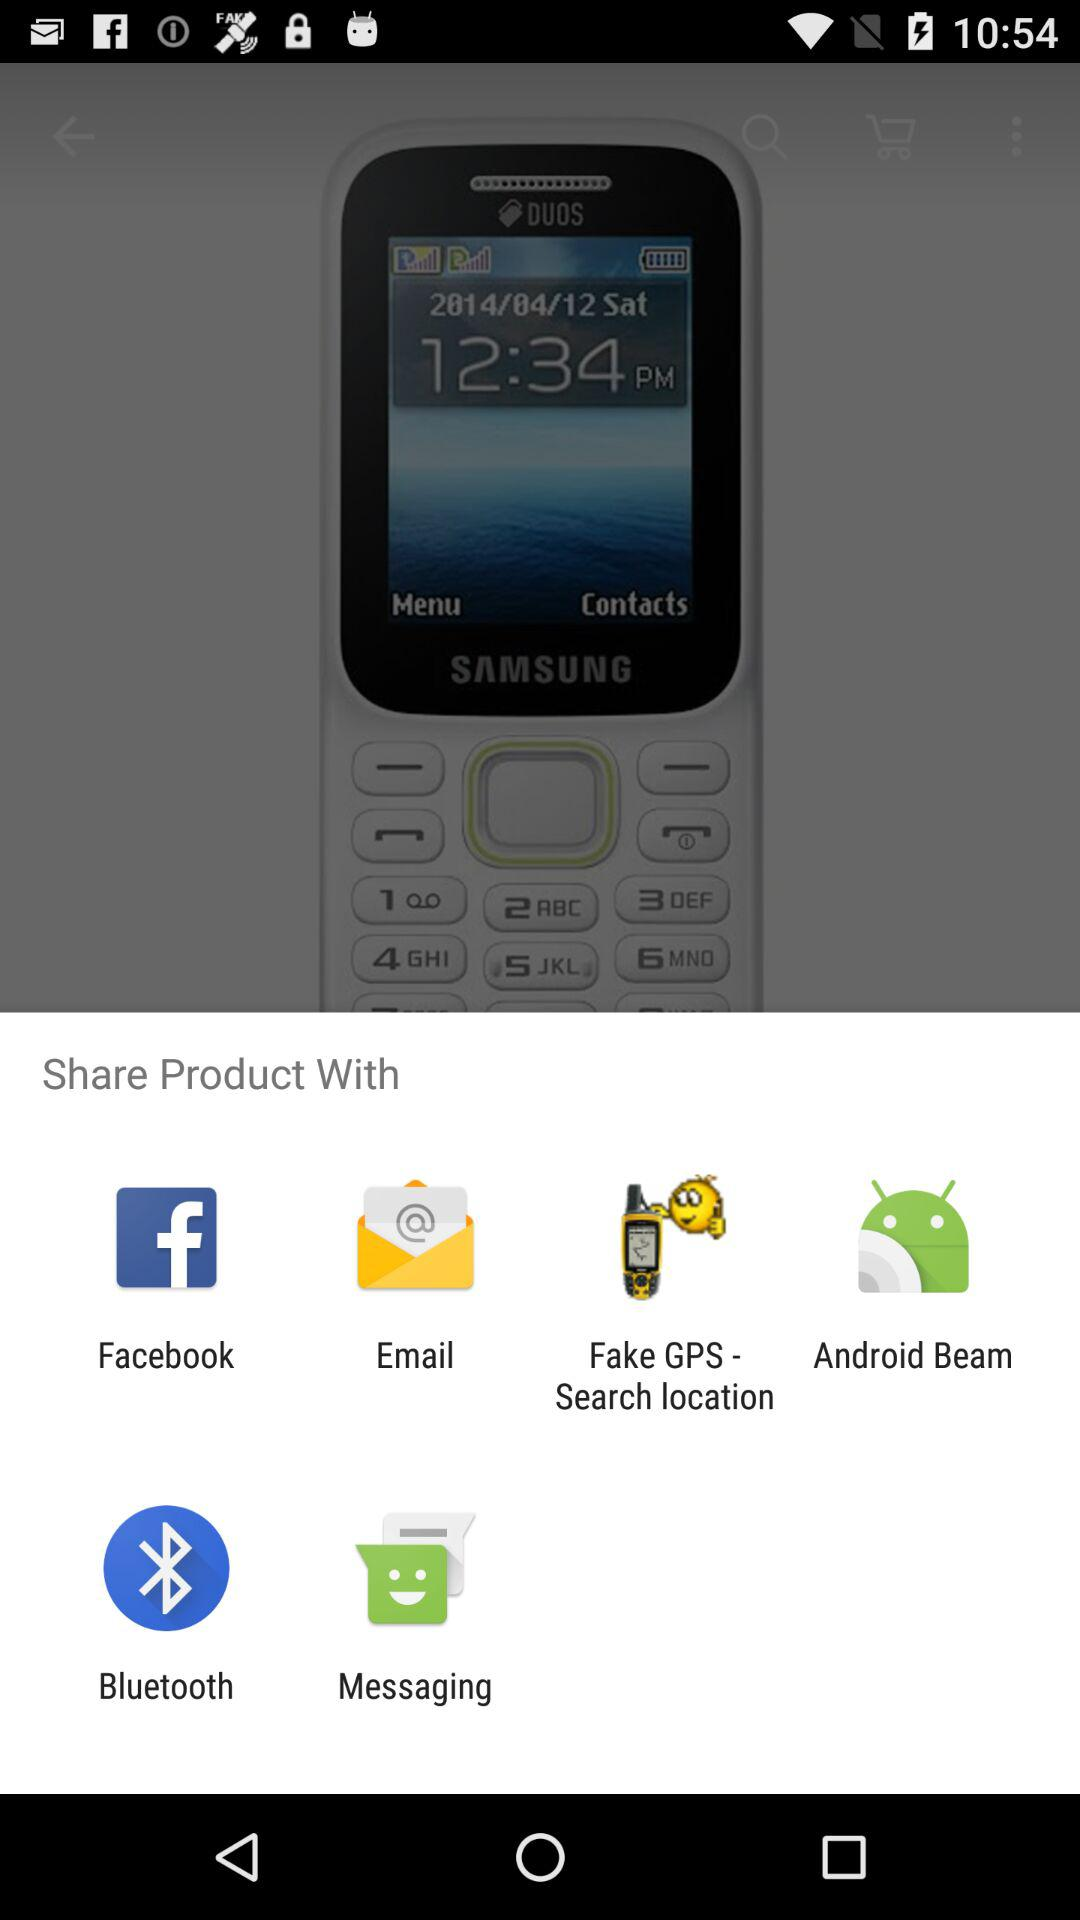What applications are used to share the product? The applications that are used to share are "Facebook", "Email", "Fake GPS - Search location", "Android Beam", "Bluetooth" and "Messaging". 